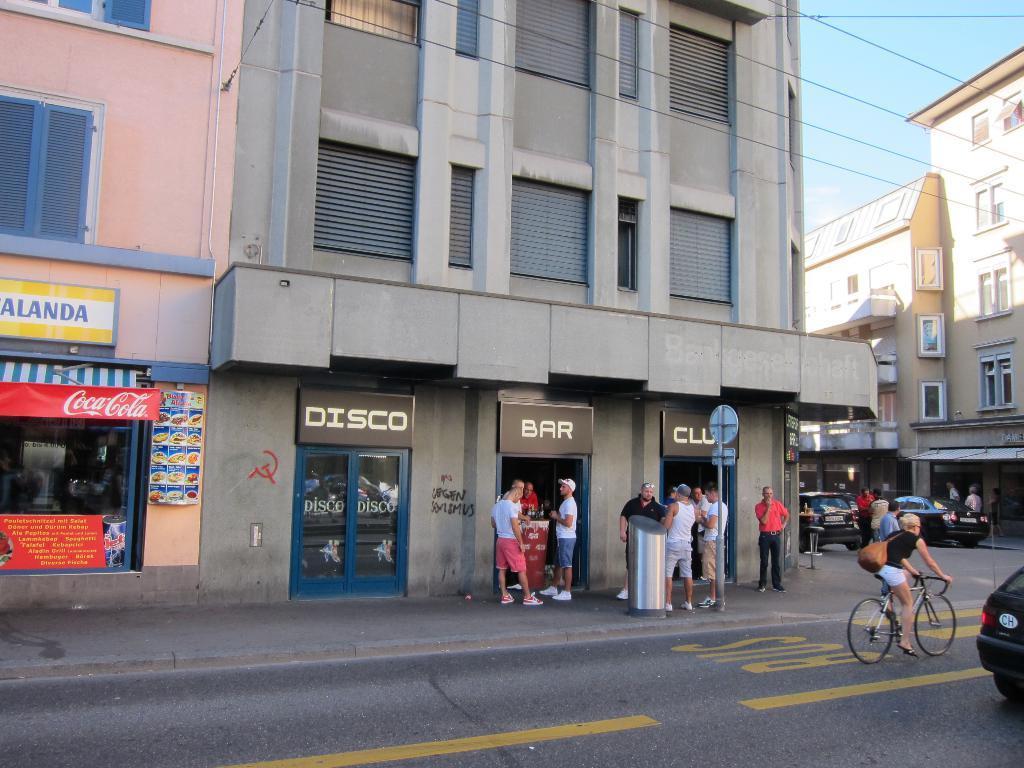Describe this image in one or two sentences. In this image we can see buildings, stores. There are people standing. At the bottom of the image there is road on which there are vehicles. At the top of the image there is sky. 